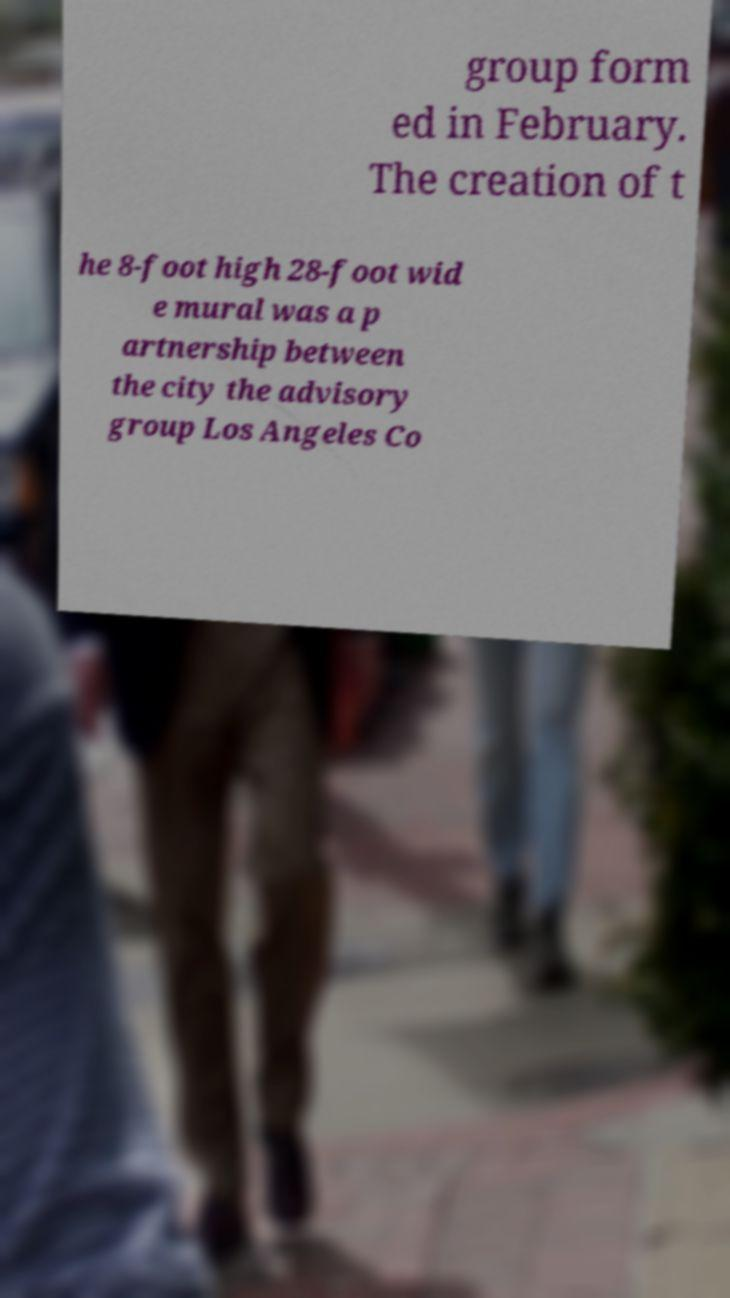Can you read and provide the text displayed in the image?This photo seems to have some interesting text. Can you extract and type it out for me? group form ed in February. The creation of t he 8-foot high 28-foot wid e mural was a p artnership between the city the advisory group Los Angeles Co 